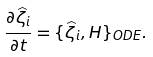Convert formula to latex. <formula><loc_0><loc_0><loc_500><loc_500>\frac { \partial \widehat { \zeta } _ { i } } { \partial t } = \{ \widehat { \zeta } _ { i } , H \} _ { O D E } .</formula> 